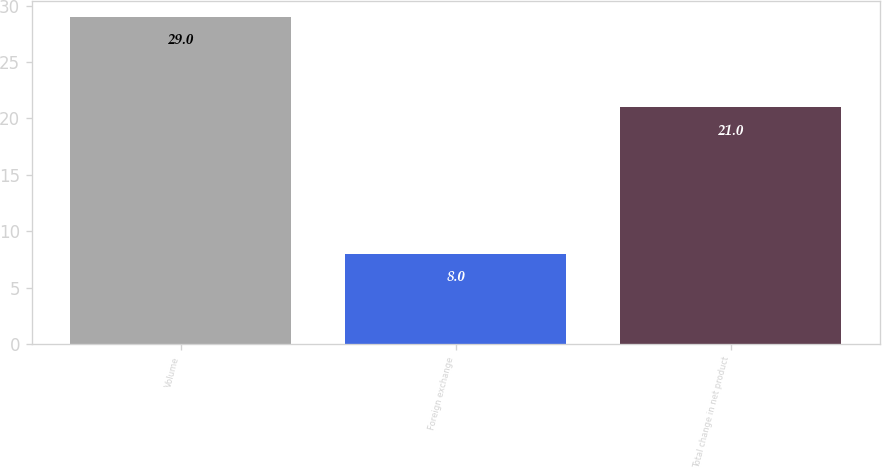Convert chart to OTSL. <chart><loc_0><loc_0><loc_500><loc_500><bar_chart><fcel>Volume<fcel>Foreign exchange<fcel>Total change in net product<nl><fcel>29<fcel>8<fcel>21<nl></chart> 